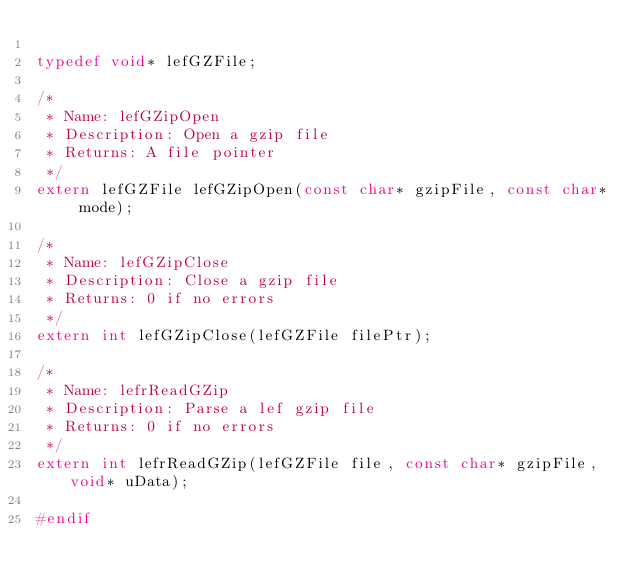Convert code to text. <code><loc_0><loc_0><loc_500><loc_500><_C++_>
typedef void* lefGZFile;

/* 
 * Name: lefGZipOpen
 * Description: Open a gzip file
 * Returns: A file pointer
 */
extern lefGZFile lefGZipOpen(const char* gzipFile, const char* mode);

/* 
 * Name: lefGZipClose
 * Description: Close a gzip file
 * Returns: 0 if no errors
 */
extern int lefGZipClose(lefGZFile filePtr);

/*
 * Name: lefrReadGZip
 * Description: Parse a lef gzip file
 * Returns: 0 if no errors
 */
extern int lefrReadGZip(lefGZFile file, const char* gzipFile, void* uData);

#endif
</code> 